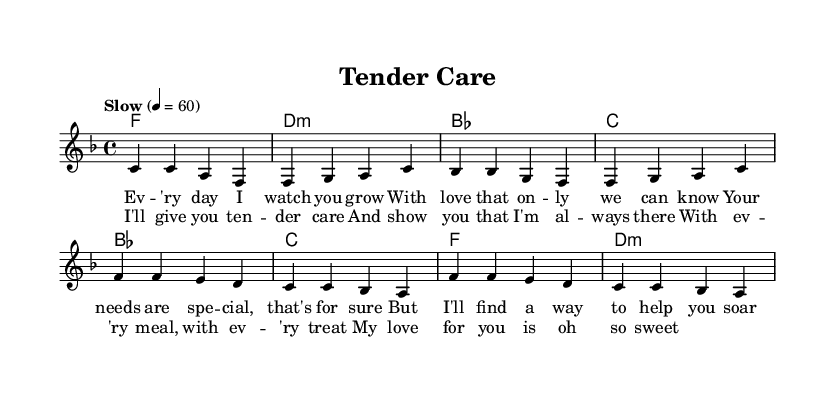What is the key signature of this music? The key signature is F major, which has one flat (B flat).
Answer: F major What is the time signature of this music? The time signature is 4/4, indicating four beats per measure.
Answer: 4/4 What is the tempo marking of this music? The tempo marking is "Slow", suggesting a relaxed pace of 60 beats per minute.
Answer: Slow How many measures are in the verse section? There are four measures in the verse section before reaching the chorus.
Answer: Four How does the chorus's ending compare to the verse's ending? The chorus ends with a repetition of notes that creates a sense of resolution, while the verse tends to be more flowing and expressive.
Answer: Resolution What theme is portrayed through the lyrics of this piece? The lyrics center around nurturing and care, indicating a deep love and commitment to someone's special needs.
Answer: Nurturing care What is the main chord progression used in the verse? The main chord progression is F, D minor, B flat, C, representing a common structure in soul music to convey emotion.
Answer: F, D minor, B flat, C 